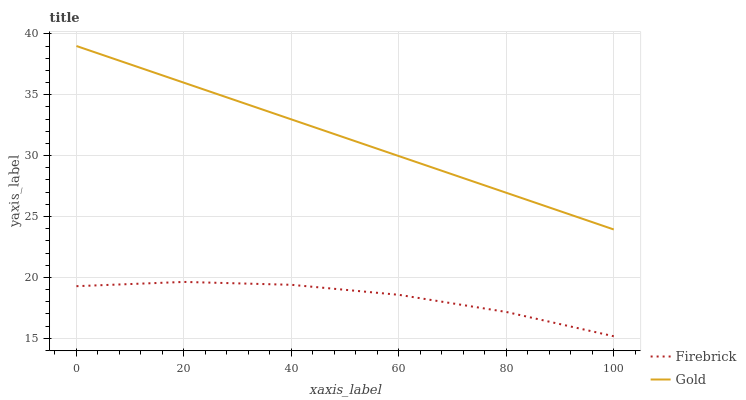Does Gold have the minimum area under the curve?
Answer yes or no. No. Is Gold the roughest?
Answer yes or no. No. Does Gold have the lowest value?
Answer yes or no. No. Is Firebrick less than Gold?
Answer yes or no. Yes. Is Gold greater than Firebrick?
Answer yes or no. Yes. Does Firebrick intersect Gold?
Answer yes or no. No. 